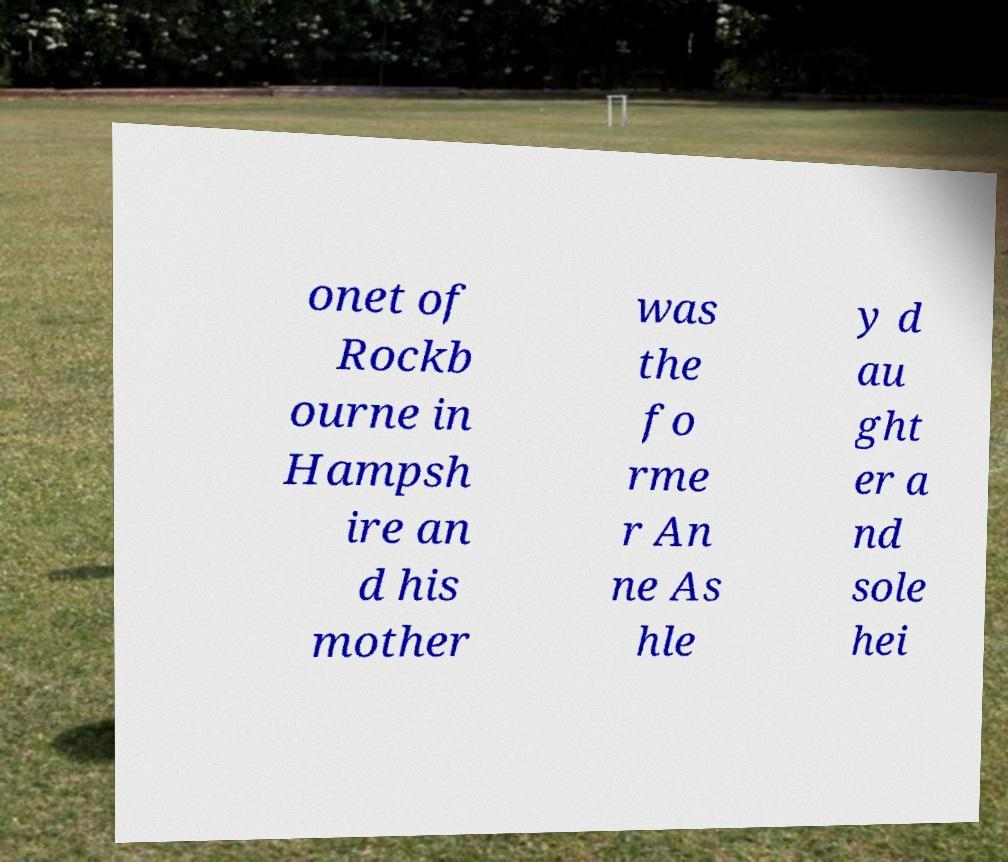Could you assist in decoding the text presented in this image and type it out clearly? onet of Rockb ourne in Hampsh ire an d his mother was the fo rme r An ne As hle y d au ght er a nd sole hei 